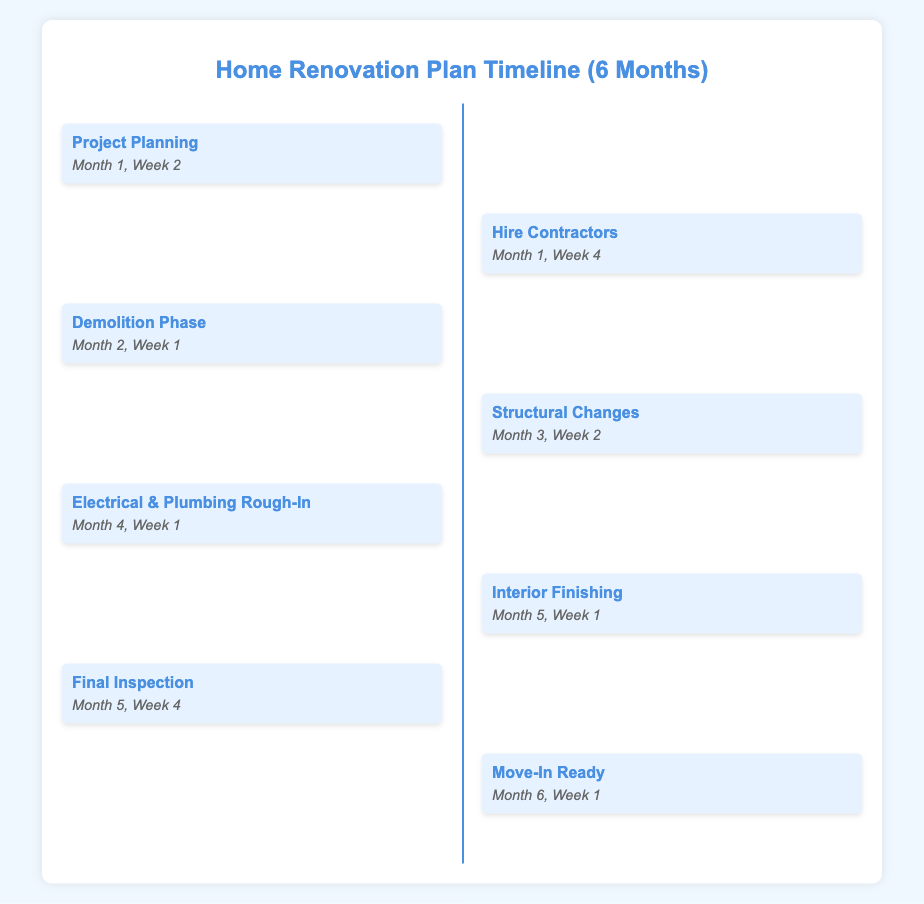What is the first milestone? The first milestone listed in the document is 'Project Planning.'
Answer: Project Planning What is the deadline for hiring contractors? The document specifies that contractors should be hired by 'Month 1, Week 4.'
Answer: Month 1, Week 4 How many milestones are there in total? The document lists a total of eight milestones for the renovation project.
Answer: 8 When does the demolition phase start? According to the document, the demolition phase starts in 'Month 2, Week 1.'
Answer: Month 2, Week 1 What is the last milestone before moving in? The last milestone before moving in is 'Final Inspection.'
Answer: Final Inspection What milestone occurs in Month 4? The document indicates that 'Electrical & Plumbing Rough-In' occurs in Month 4.
Answer: Electrical & Plumbing Rough-In What week does the interior finishing begin? The document states that interior finishing begins in 'Month 5, Week 1.'
Answer: Month 5, Week 1 What is the milestone that marks the end of the renovation plan? The last milestone indicating the completion of the renovation plan is 'Move-In Ready.'
Answer: Move-In Ready 